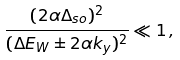<formula> <loc_0><loc_0><loc_500><loc_500>\frac { ( 2 \alpha \Delta _ { s o } ) ^ { 2 } } { ( \Delta E _ { W } \pm 2 \alpha k _ { y } ) ^ { 2 } } \ll 1 \, ,</formula> 